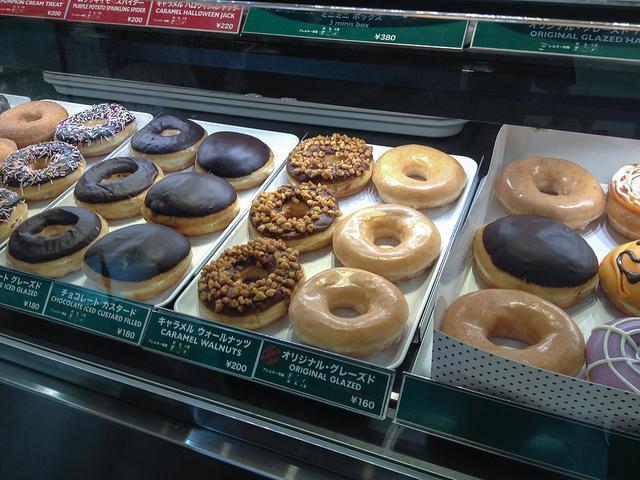Where can you buy these donuts?
Indicate the correct choice and explain in the format: 'Answer: answer
Rationale: rationale.'
Options: Japan, south korea, china, singapore. Answer: japan.
Rationale: The donuts are in japan. 